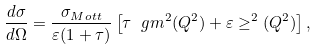<formula> <loc_0><loc_0><loc_500><loc_500>\frac { d \sigma } { d \Omega } = \frac { \sigma _ { M o t t } } { \varepsilon ( 1 + \tau ) } \left [ \tau \ g m ^ { 2 } ( Q ^ { 2 } ) + \varepsilon \geq ^ { 2 } ( Q ^ { 2 } ) \right ] ,</formula> 